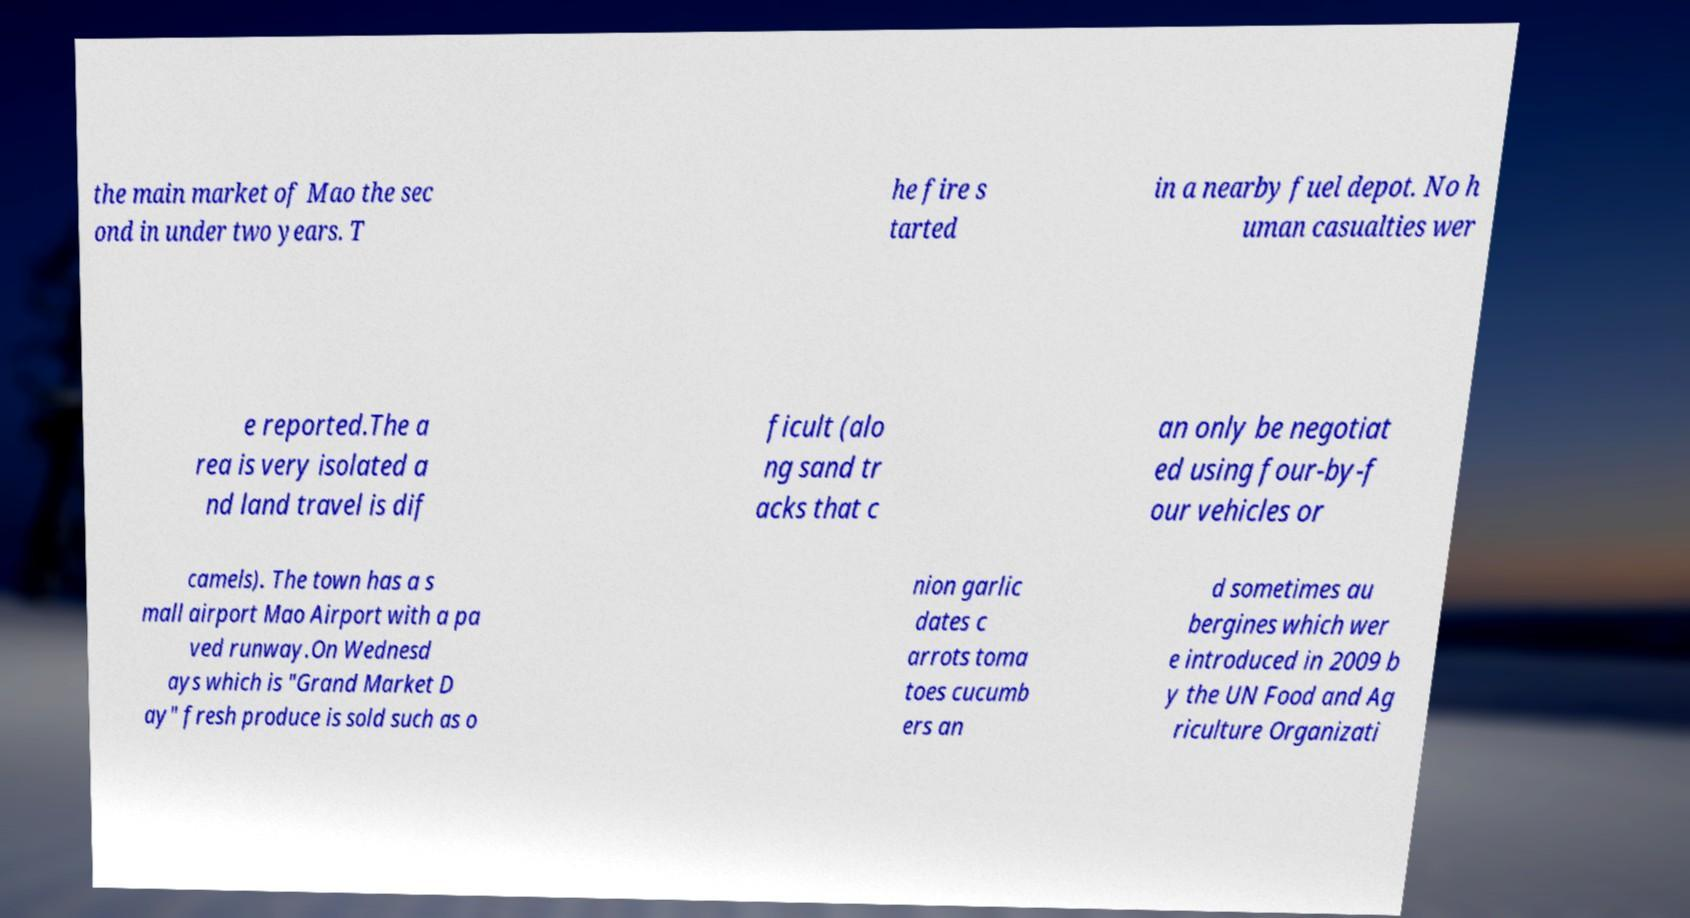Please identify and transcribe the text found in this image. the main market of Mao the sec ond in under two years. T he fire s tarted in a nearby fuel depot. No h uman casualties wer e reported.The a rea is very isolated a nd land travel is dif ficult (alo ng sand tr acks that c an only be negotiat ed using four-by-f our vehicles or camels). The town has a s mall airport Mao Airport with a pa ved runway.On Wednesd ays which is "Grand Market D ay" fresh produce is sold such as o nion garlic dates c arrots toma toes cucumb ers an d sometimes au bergines which wer e introduced in 2009 b y the UN Food and Ag riculture Organizati 